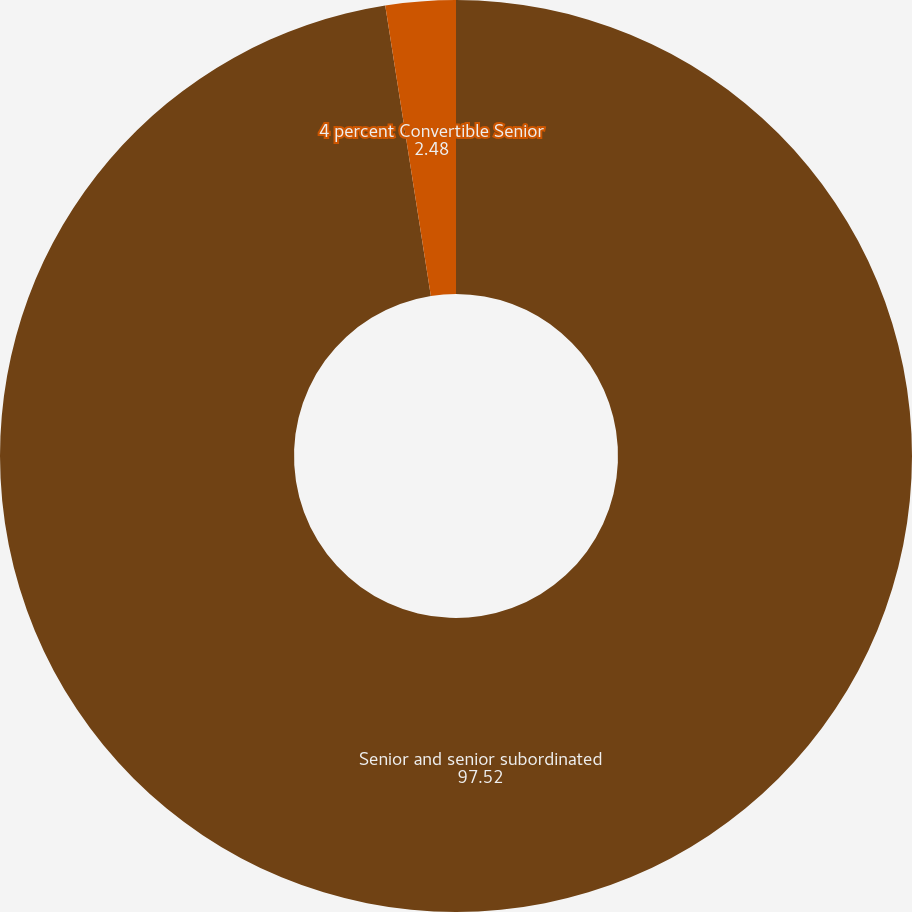Convert chart. <chart><loc_0><loc_0><loc_500><loc_500><pie_chart><fcel>Senior and senior subordinated<fcel>4 percent Convertible Senior<nl><fcel>97.52%<fcel>2.48%<nl></chart> 